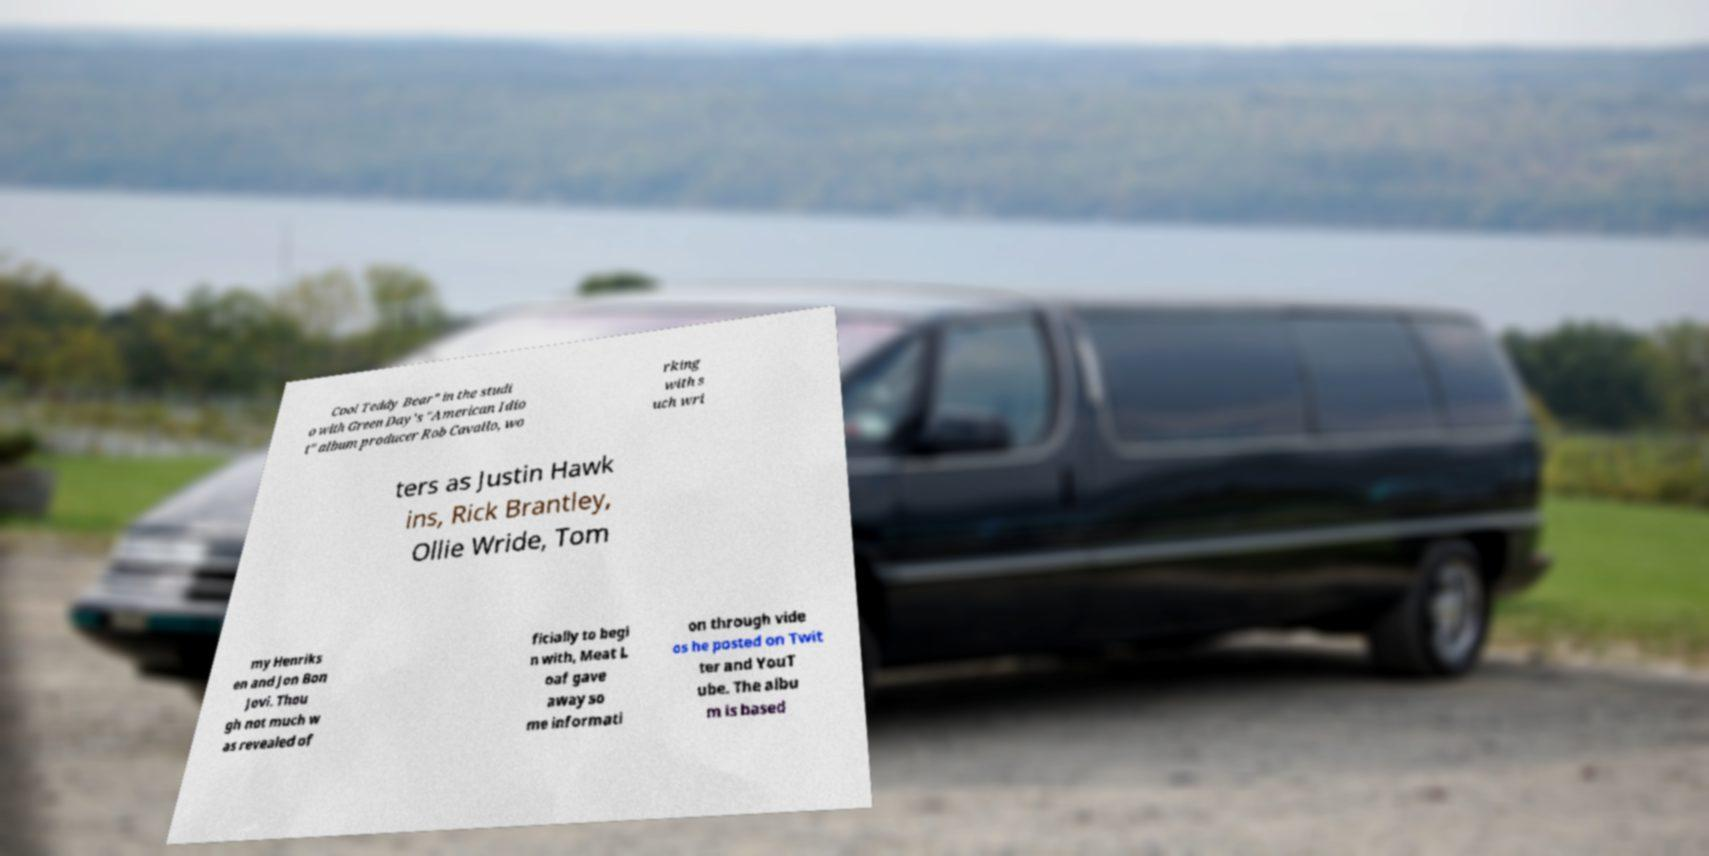Can you read and provide the text displayed in the image?This photo seems to have some interesting text. Can you extract and type it out for me? Cool Teddy Bear" in the studi o with Green Day's "American Idio t" album producer Rob Cavallo, wo rking with s uch wri ters as Justin Hawk ins, Rick Brantley, Ollie Wride, Tom my Henriks en and Jon Bon Jovi. Thou gh not much w as revealed of ficially to begi n with, Meat L oaf gave away so me informati on through vide os he posted on Twit ter and YouT ube. The albu m is based 